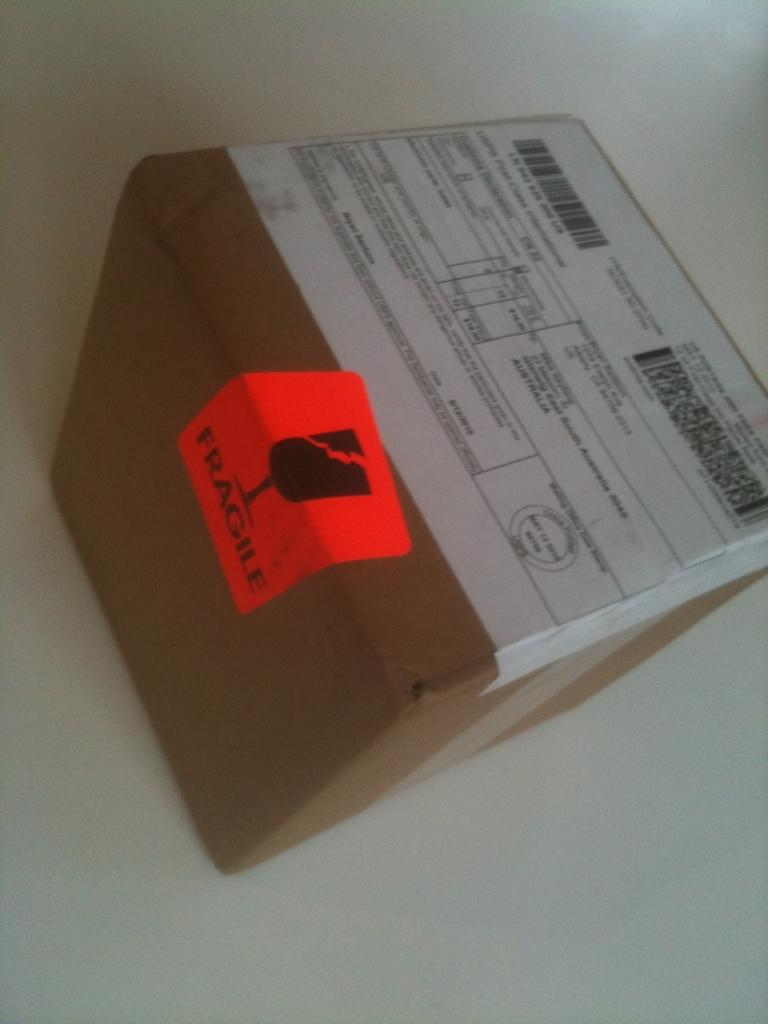<image>
Share a concise interpretation of the image provided. AN orange fragile sticker is on the edge of a box. 